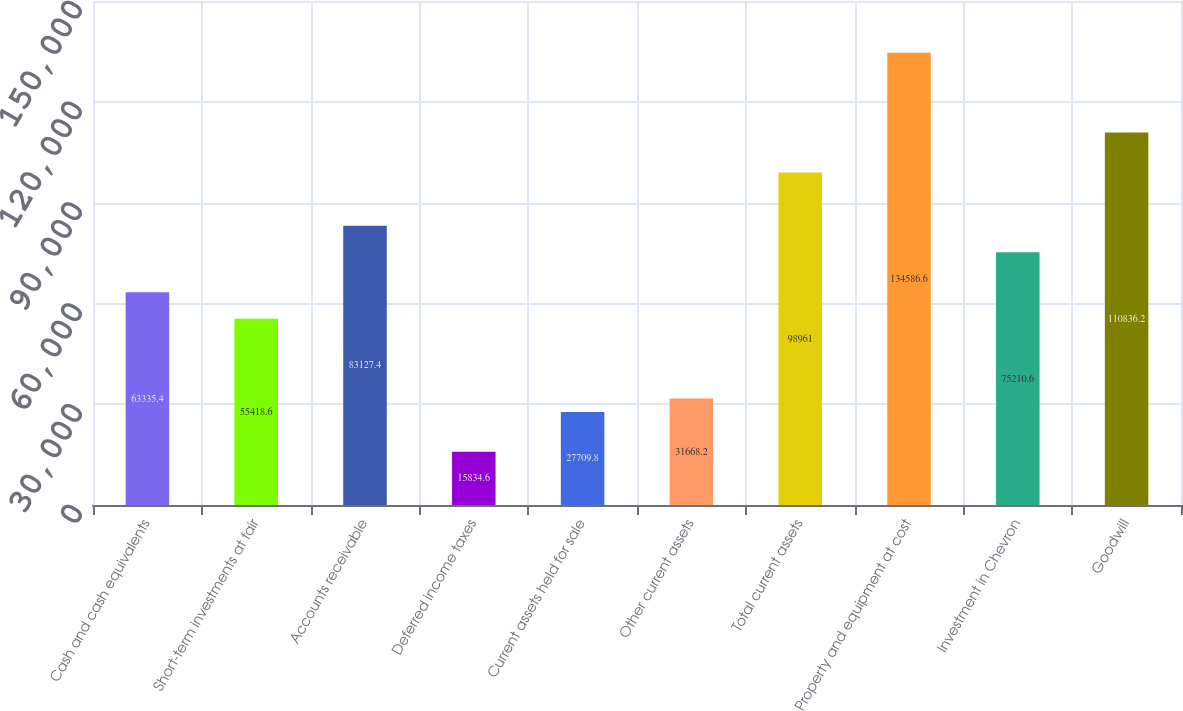Convert chart. <chart><loc_0><loc_0><loc_500><loc_500><bar_chart><fcel>Cash and cash equivalents<fcel>Short-term investments at fair<fcel>Accounts receivable<fcel>Deferred income taxes<fcel>Current assets held for sale<fcel>Other current assets<fcel>Total current assets<fcel>Property and equipment at cost<fcel>Investment in Chevron<fcel>Goodwill<nl><fcel>63335.4<fcel>55418.6<fcel>83127.4<fcel>15834.6<fcel>27709.8<fcel>31668.2<fcel>98961<fcel>134587<fcel>75210.6<fcel>110836<nl></chart> 